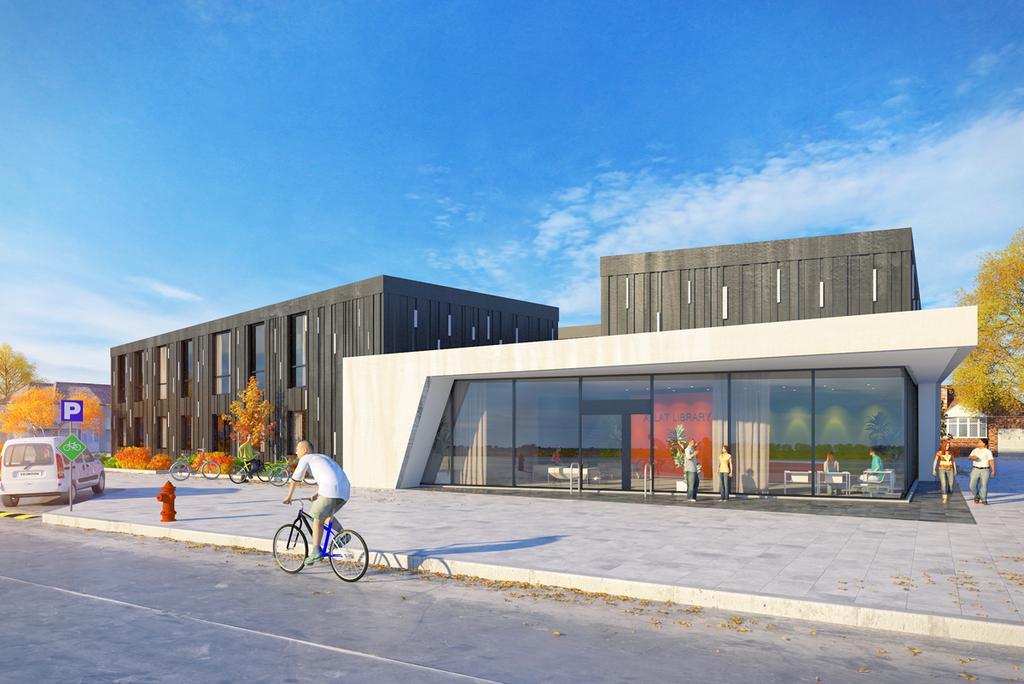Can you describe this image briefly? This is an animated image. At the bottom, I can see the road and one person is riding the bicycle. On the left side there is a car. On the right side two persons are walking on the ground. In the middle of the image there are few buildings and trees. In front of a building two persons are standing. At the top of the image I can see the sky and clouds. 